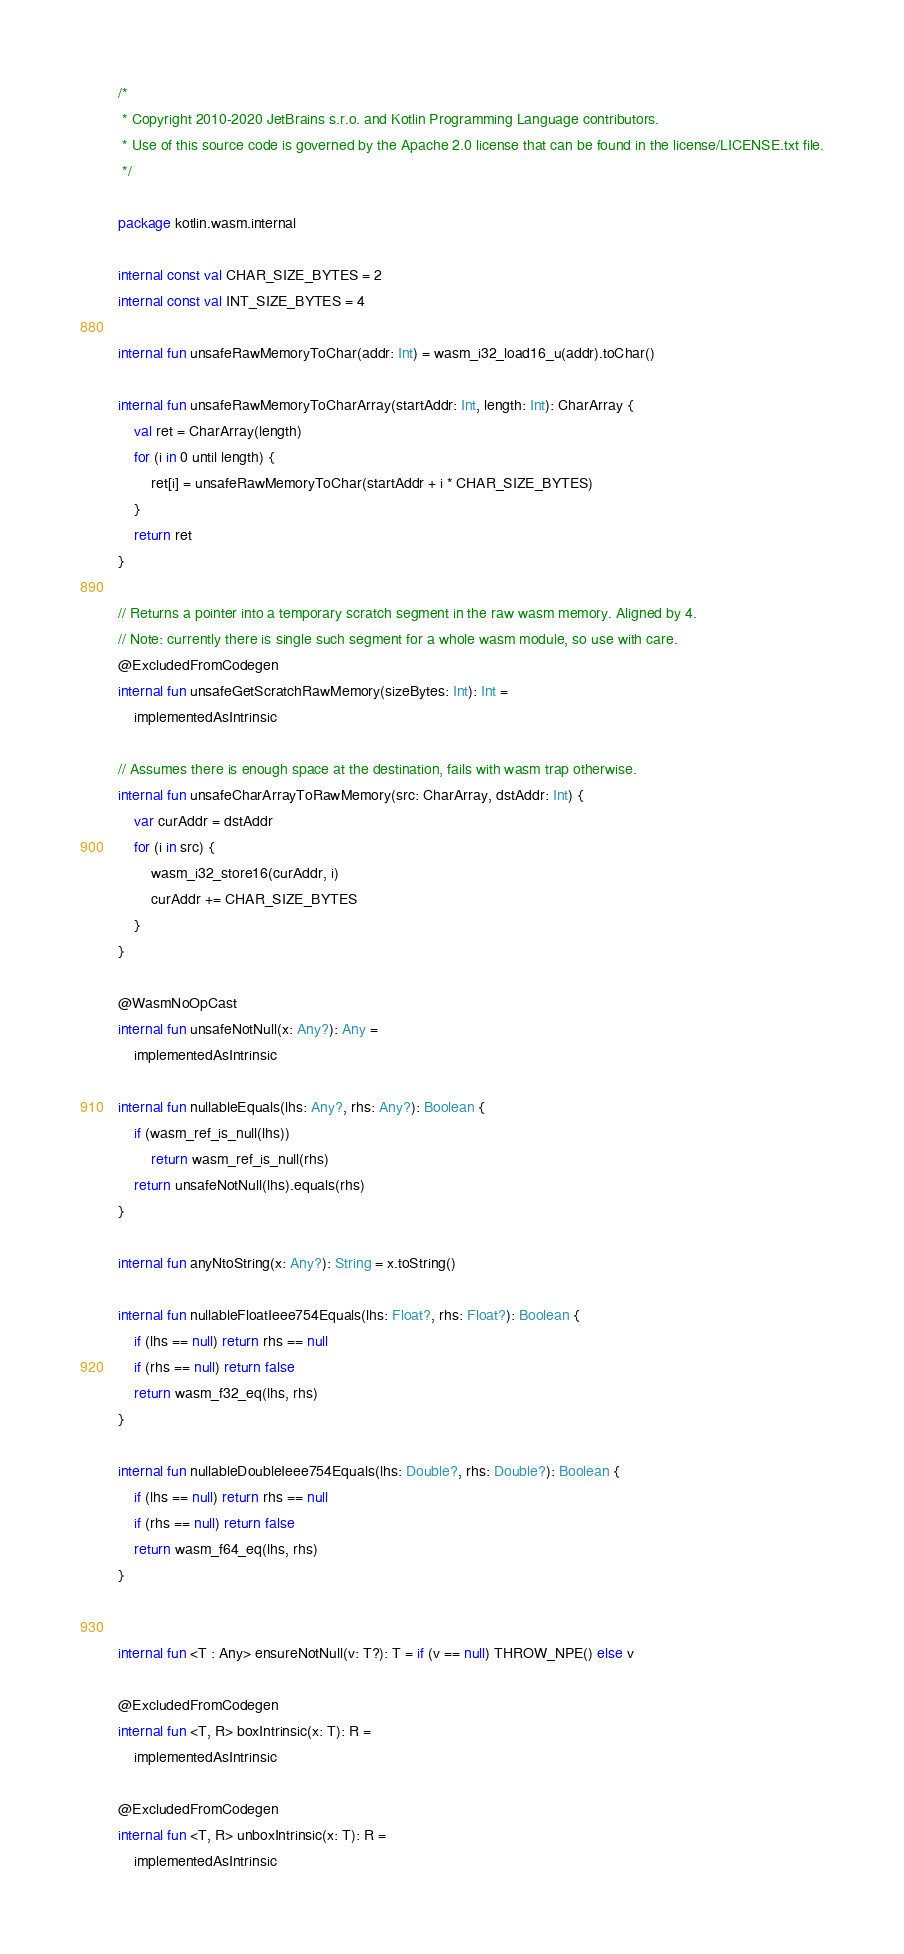<code> <loc_0><loc_0><loc_500><loc_500><_Kotlin_>/*
 * Copyright 2010-2020 JetBrains s.r.o. and Kotlin Programming Language contributors.
 * Use of this source code is governed by the Apache 2.0 license that can be found in the license/LICENSE.txt file.
 */

package kotlin.wasm.internal

internal const val CHAR_SIZE_BYTES = 2
internal const val INT_SIZE_BYTES = 4

internal fun unsafeRawMemoryToChar(addr: Int) = wasm_i32_load16_u(addr).toChar()

internal fun unsafeRawMemoryToCharArray(startAddr: Int, length: Int): CharArray {
    val ret = CharArray(length)
    for (i in 0 until length) {
        ret[i] = unsafeRawMemoryToChar(startAddr + i * CHAR_SIZE_BYTES)
    }
    return ret
}

// Returns a pointer into a temporary scratch segment in the raw wasm memory. Aligned by 4.
// Note: currently there is single such segment for a whole wasm module, so use with care.
@ExcludedFromCodegen
internal fun unsafeGetScratchRawMemory(sizeBytes: Int): Int =
    implementedAsIntrinsic

// Assumes there is enough space at the destination, fails with wasm trap otherwise.
internal fun unsafeCharArrayToRawMemory(src: CharArray, dstAddr: Int) {
    var curAddr = dstAddr
    for (i in src) {
        wasm_i32_store16(curAddr, i)
        curAddr += CHAR_SIZE_BYTES
    }
}

@WasmNoOpCast
internal fun unsafeNotNull(x: Any?): Any =
    implementedAsIntrinsic

internal fun nullableEquals(lhs: Any?, rhs: Any?): Boolean {
    if (wasm_ref_is_null(lhs))
        return wasm_ref_is_null(rhs)
    return unsafeNotNull(lhs).equals(rhs)
}

internal fun anyNtoString(x: Any?): String = x.toString()

internal fun nullableFloatIeee754Equals(lhs: Float?, rhs: Float?): Boolean {
    if (lhs == null) return rhs == null
    if (rhs == null) return false
    return wasm_f32_eq(lhs, rhs)
}

internal fun nullableDoubleIeee754Equals(lhs: Double?, rhs: Double?): Boolean {
    if (lhs == null) return rhs == null
    if (rhs == null) return false
    return wasm_f64_eq(lhs, rhs)
}


internal fun <T : Any> ensureNotNull(v: T?): T = if (v == null) THROW_NPE() else v

@ExcludedFromCodegen
internal fun <T, R> boxIntrinsic(x: T): R =
    implementedAsIntrinsic

@ExcludedFromCodegen
internal fun <T, R> unboxIntrinsic(x: T): R =
    implementedAsIntrinsic
</code> 